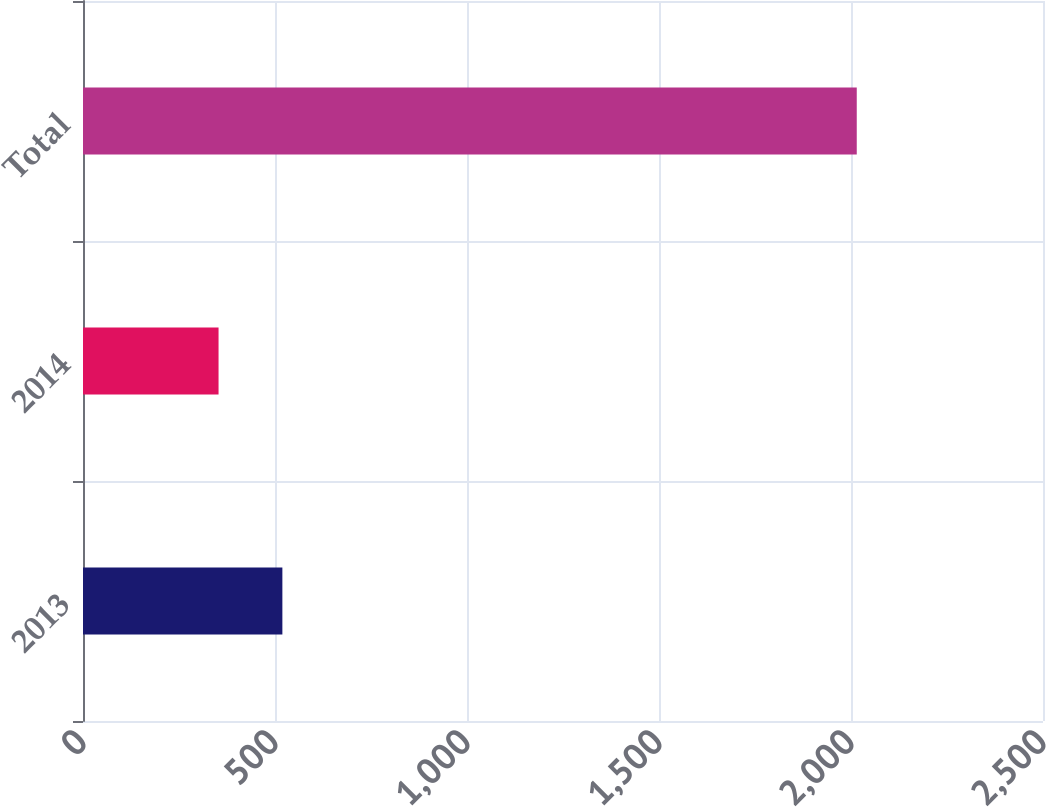Convert chart to OTSL. <chart><loc_0><loc_0><loc_500><loc_500><bar_chart><fcel>2013<fcel>2014<fcel>Total<nl><fcel>519.2<fcel>353<fcel>2015<nl></chart> 